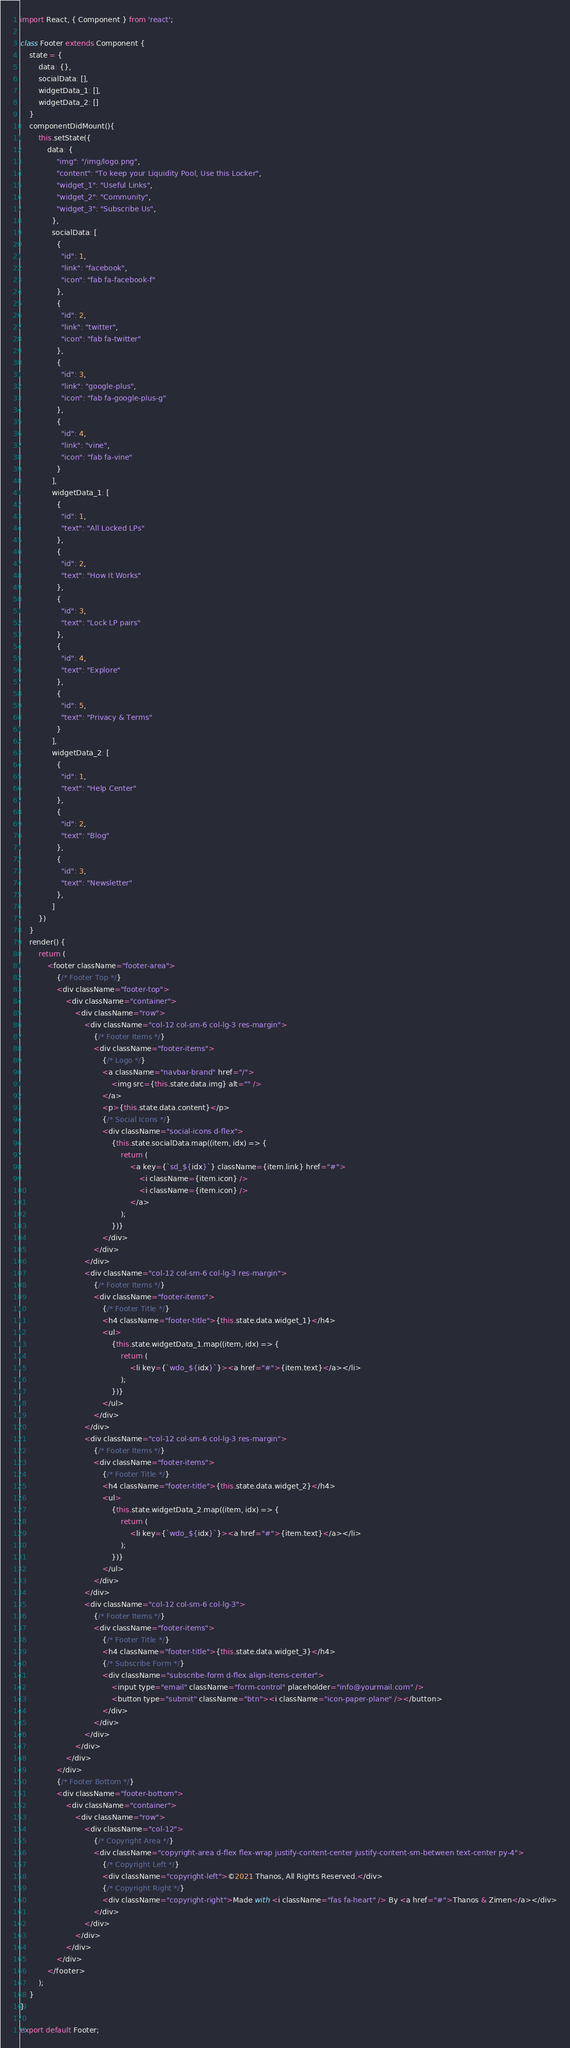Convert code to text. <code><loc_0><loc_0><loc_500><loc_500><_JavaScript_>import React, { Component } from 'react';

class Footer extends Component {
    state = {
        data: {},
        socialData: [],
        widgetData_1: [],
        widgetData_2: []
    }
    componentDidMount(){
        this.setState({
            data: {
                "img": "/img/logo.png",
                "content": "To keep your Liquidity Pool, Use this Locker",
                "widget_1": "Useful Links",
                "widget_2": "Community",
                "widget_3": "Subscribe Us",
              },
              socialData: [
                {
                  "id": 1,
                  "link": "facebook",
                  "icon": "fab fa-facebook-f"
                },
                {
                  "id": 2,
                  "link": "twitter",
                  "icon": "fab fa-twitter"
                },
                {
                  "id": 3,
                  "link": "google-plus",
                  "icon": "fab fa-google-plus-g"
                },
                {
                  "id": 4,
                  "link": "vine",
                  "icon": "fab fa-vine"
                }
              ],
              widgetData_1: [
                {
                  "id": 1,
                  "text": "All Locked LPs"
                },
                {
                  "id": 2,
                  "text": "How It Works"
                },
                {
                  "id": 3,
                  "text": "Lock LP pairs"
                },
                {
                  "id": 4,
                  "text": "Explore"
                },
                {
                  "id": 5,
                  "text": "Privacy & Terms"
                }
              ],
              widgetData_2: [
                {
                  "id": 1,
                  "text": "Help Center"
                },
                {
                  "id": 2,
                  "text": "Blog"
                },
                {
                  "id": 3,
                  "text": "Newsletter"
                },
              ]
        })
    }
    render() {
        return (
            <footer className="footer-area">
                {/* Footer Top */}
                <div className="footer-top">
                    <div className="container">
                        <div className="row">
                            <div className="col-12 col-sm-6 col-lg-3 res-margin">
                                {/* Footer Items */}
                                <div className="footer-items">
                                    {/* Logo */}
                                    <a className="navbar-brand" href="/">
                                        <img src={this.state.data.img} alt="" />
                                    </a>
                                    <p>{this.state.data.content}</p>
                                    {/* Social Icons */}
                                    <div className="social-icons d-flex">
                                        {this.state.socialData.map((item, idx) => {
                                            return (
                                                <a key={`sd_${idx}`} className={item.link} href="#">
                                                    <i className={item.icon} />
                                                    <i className={item.icon} />
                                                </a>
                                            );
                                        })}
                                    </div>
                                </div>
                            </div>
                            <div className="col-12 col-sm-6 col-lg-3 res-margin">
                                {/* Footer Items */}
                                <div className="footer-items">
                                    {/* Footer Title */}
                                    <h4 className="footer-title">{this.state.data.widget_1}</h4>
                                    <ul>
                                        {this.state.widgetData_1.map((item, idx) => {
                                            return (
                                                <li key={`wdo_${idx}`}><a href="#">{item.text}</a></li>
                                            );
                                        })}
                                    </ul>
                                </div>
                            </div>
                            <div className="col-12 col-sm-6 col-lg-3 res-margin">
                                {/* Footer Items */}
                                <div className="footer-items">
                                    {/* Footer Title */}
                                    <h4 className="footer-title">{this.state.data.widget_2}</h4>
                                    <ul>
                                        {this.state.widgetData_2.map((item, idx) => {
                                            return (
                                                <li key={`wdo_${idx}`}><a href="#">{item.text}</a></li>
                                            );
                                        })}
                                    </ul>
                                </div>
                            </div>
                            <div className="col-12 col-sm-6 col-lg-3">
                                {/* Footer Items */}
                                <div className="footer-items">
                                    {/* Footer Title */}
                                    <h4 className="footer-title">{this.state.data.widget_3}</h4>
                                    {/* Subscribe Form */}
                                    <div className="subscribe-form d-flex align-items-center">
                                        <input type="email" className="form-control" placeholder="info@yourmail.com" />
                                        <button type="submit" className="btn"><i className="icon-paper-plane" /></button>
                                    </div>
                                </div>
                            </div>
                        </div>
                    </div>
                </div>
                {/* Footer Bottom */}
                <div className="footer-bottom">
                    <div className="container">
                        <div className="row">
                            <div className="col-12">
                                {/* Copyright Area */}
                                <div className="copyright-area d-flex flex-wrap justify-content-center justify-content-sm-between text-center py-4">
                                    {/* Copyright Left */}
                                    <div className="copyright-left">©2021 Thanos, All Rights Reserved.</div>
                                    {/* Copyright Right */}
                                    <div className="copyright-right">Made with <i className="fas fa-heart" /> By <a href="#">Thanos & Zimen</a></div>
                                </div>
                            </div>
                        </div>
                    </div>
                </div>
            </footer>
        );
    }
}

export default Footer;</code> 